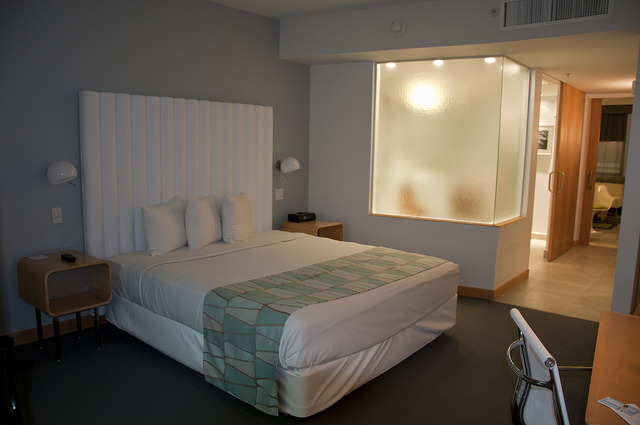What style of decor does this room have? The room features a contemporary style with minimalist furniture and neutral color tones. The prominent lighting and large backlit glass pane give it a modern and somewhat chic aesthetic. 